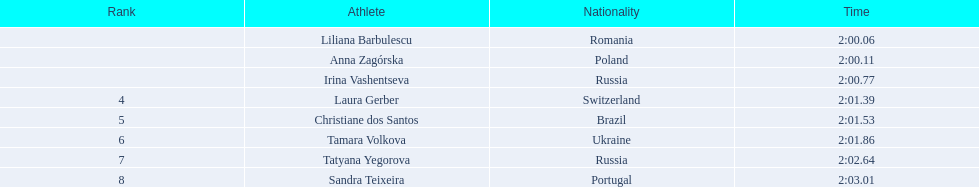What are the appellations of the contenders? Liliana Barbulescu, Anna Zagórska, Irina Vashentseva, Laura Gerber, Christiane dos Santos, Tamara Volkova, Tatyana Yegorova, Sandra Teixeira. Which finalist completed the quickest? Liliana Barbulescu. 